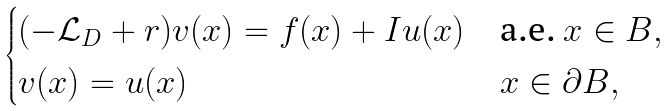Convert formula to latex. <formula><loc_0><loc_0><loc_500><loc_500>\begin{cases} ( - \mathcal { L } _ { D } + r ) v ( x ) = f ( x ) + I u ( x ) & \text {a.e.} \ x \in B , \\ v ( x ) = u ( x ) & x \in \partial B , \end{cases}</formula> 